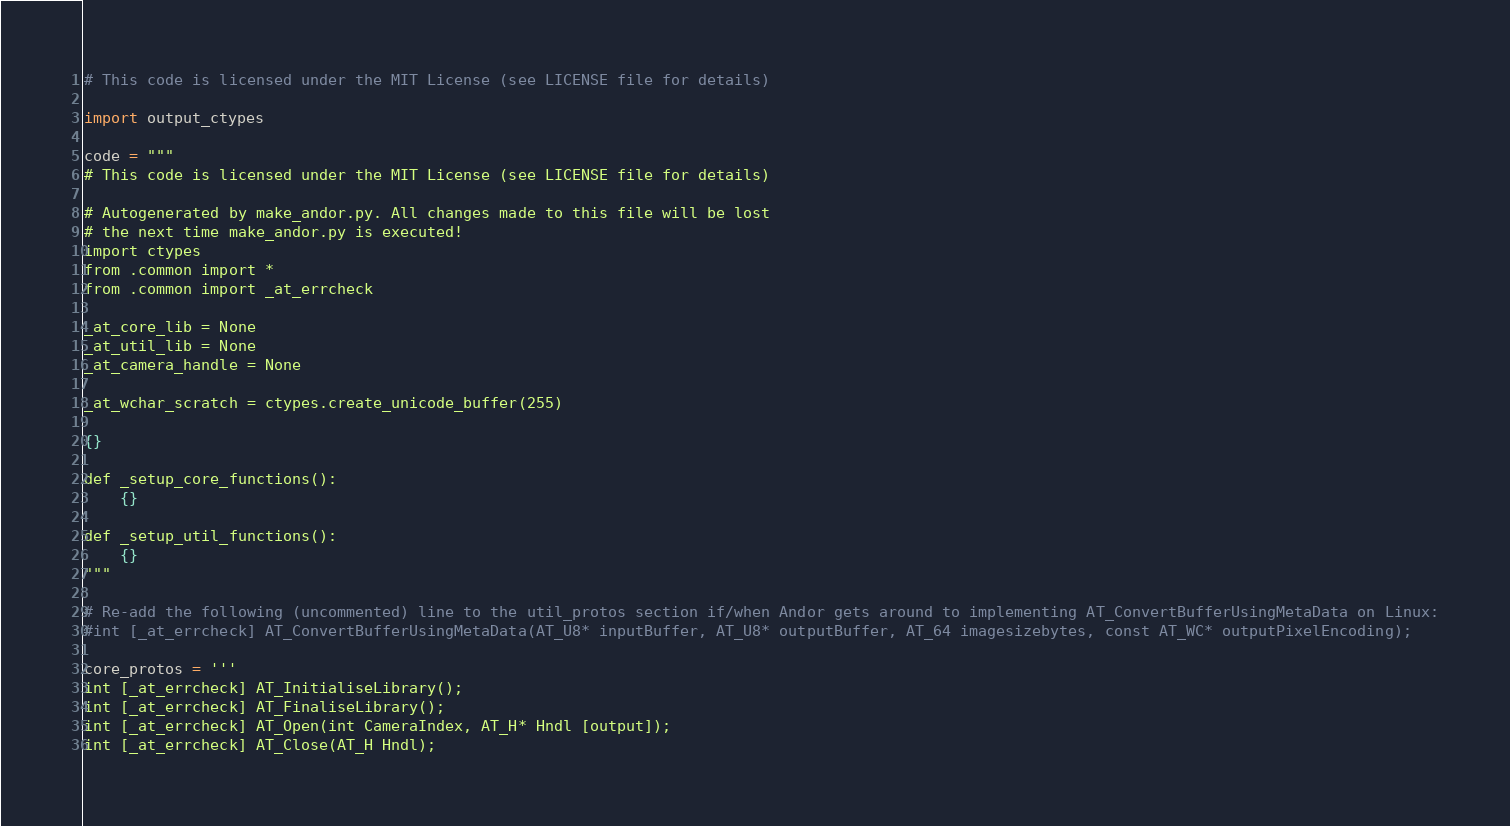<code> <loc_0><loc_0><loc_500><loc_500><_Python_># This code is licensed under the MIT License (see LICENSE file for details)

import output_ctypes

code = """
# This code is licensed under the MIT License (see LICENSE file for details)

# Autogenerated by make_andor.py. All changes made to this file will be lost
# the next time make_andor.py is executed!
import ctypes
from .common import *
from .common import _at_errcheck

_at_core_lib = None
_at_util_lib = None
_at_camera_handle = None

_at_wchar_scratch = ctypes.create_unicode_buffer(255)

{}

def _setup_core_functions():
    {}

def _setup_util_functions():
    {}
"""

# Re-add the following (uncommented) line to the util_protos section if/when Andor gets around to implementing AT_ConvertBufferUsingMetaData on Linux:
#int [_at_errcheck] AT_ConvertBufferUsingMetaData(AT_U8* inputBuffer, AT_U8* outputBuffer, AT_64 imagesizebytes, const AT_WC* outputPixelEncoding);

core_protos = '''
int [_at_errcheck] AT_InitialiseLibrary();
int [_at_errcheck] AT_FinaliseLibrary();
int [_at_errcheck] AT_Open(int CameraIndex, AT_H* Hndl [output]);
int [_at_errcheck] AT_Close(AT_H Hndl);</code> 